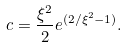Convert formula to latex. <formula><loc_0><loc_0><loc_500><loc_500>c = \frac { \xi ^ { 2 } } { 2 } e ^ { ( 2 / \xi ^ { 2 } - 1 ) } .</formula> 